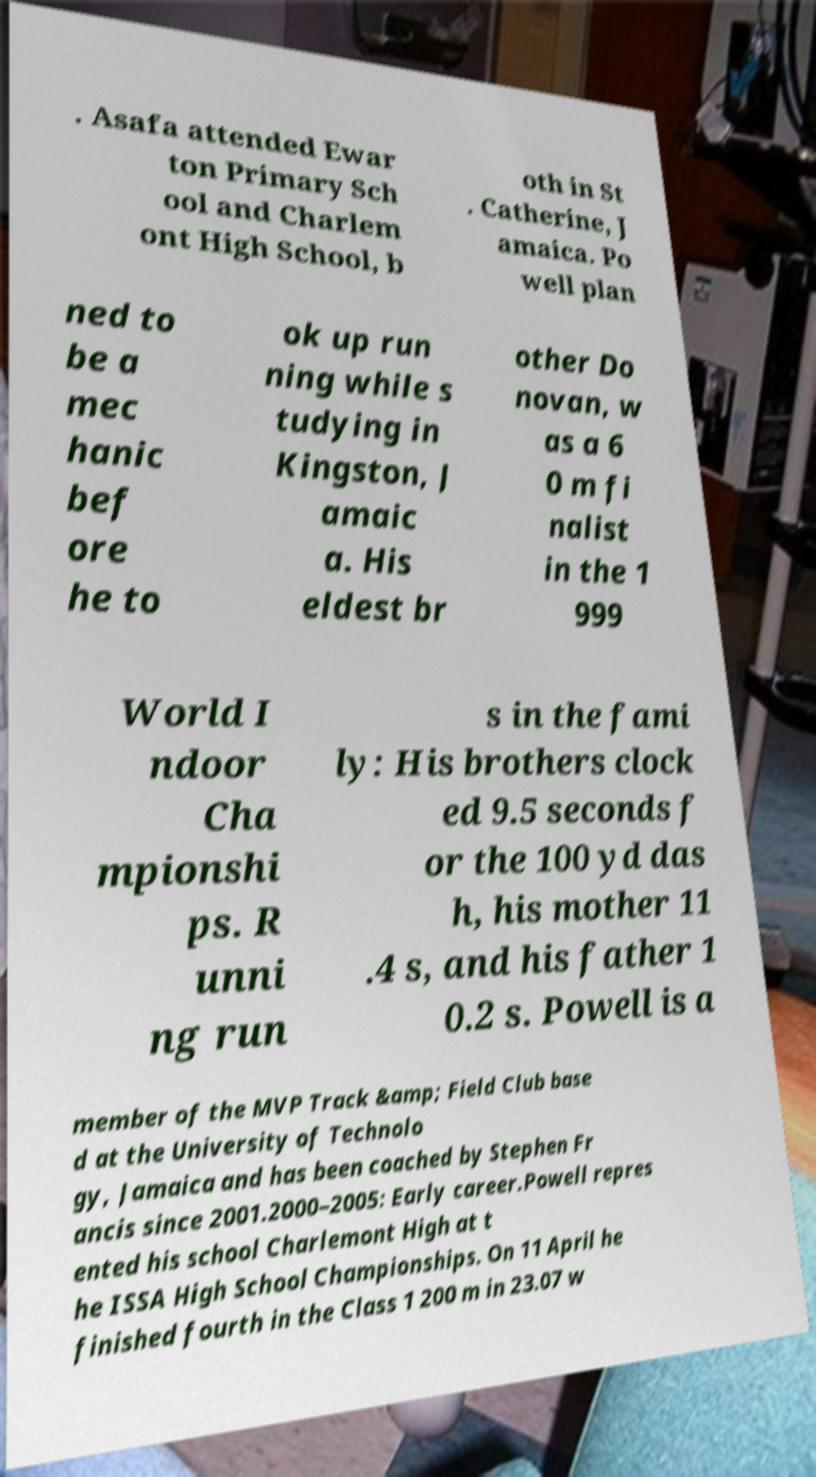Please identify and transcribe the text found in this image. . Asafa attended Ewar ton Primary Sch ool and Charlem ont High School, b oth in St . Catherine, J amaica. Po well plan ned to be a mec hanic bef ore he to ok up run ning while s tudying in Kingston, J amaic a. His eldest br other Do novan, w as a 6 0 m fi nalist in the 1 999 World I ndoor Cha mpionshi ps. R unni ng run s in the fami ly: His brothers clock ed 9.5 seconds f or the 100 yd das h, his mother 11 .4 s, and his father 1 0.2 s. Powell is a member of the MVP Track &amp; Field Club base d at the University of Technolo gy, Jamaica and has been coached by Stephen Fr ancis since 2001.2000–2005: Early career.Powell repres ented his school Charlemont High at t he ISSA High School Championships. On 11 April he finished fourth in the Class 1 200 m in 23.07 w 